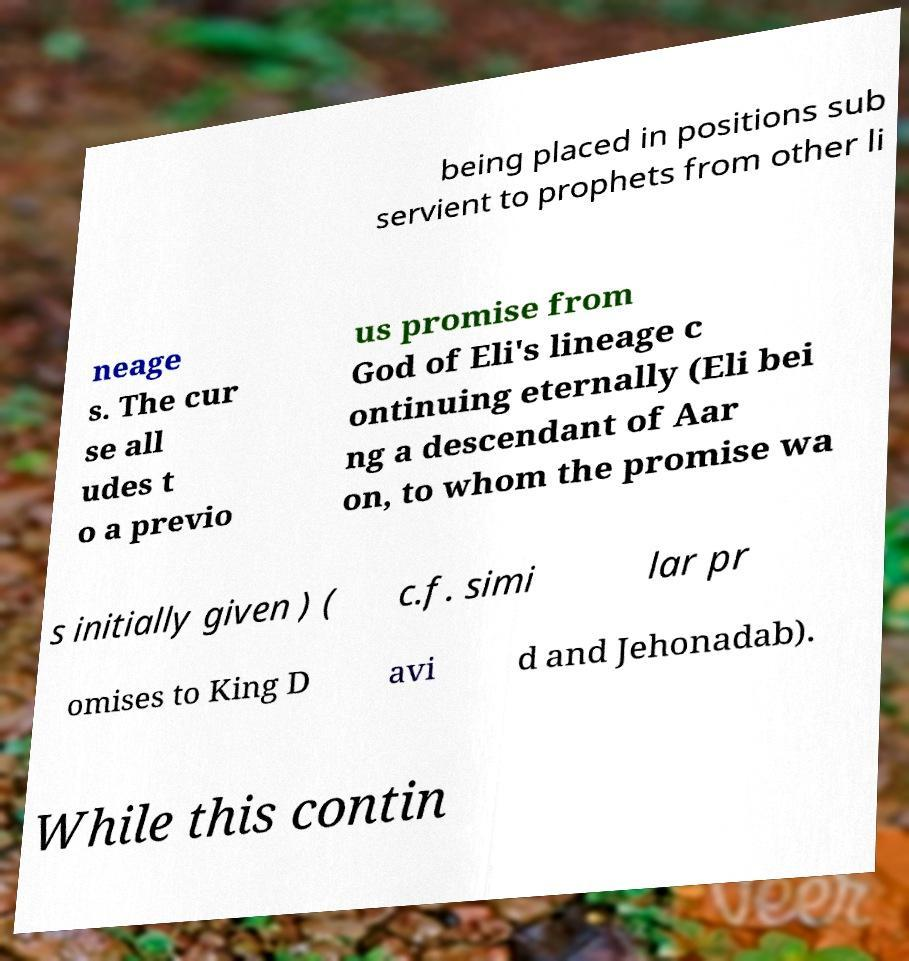What messages or text are displayed in this image? I need them in a readable, typed format. being placed in positions sub servient to prophets from other li neage s. The cur se all udes t o a previo us promise from God of Eli's lineage c ontinuing eternally (Eli bei ng a descendant of Aar on, to whom the promise wa s initially given ) ( c.f. simi lar pr omises to King D avi d and Jehonadab). While this contin 